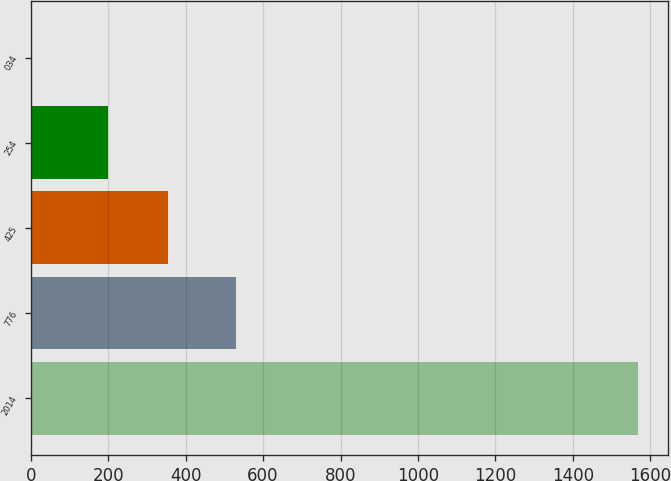Convert chart to OTSL. <chart><loc_0><loc_0><loc_500><loc_500><bar_chart><fcel>2014<fcel>776<fcel>425<fcel>254<fcel>034<nl><fcel>1568<fcel>529<fcel>355.77<fcel>199<fcel>0.27<nl></chart> 